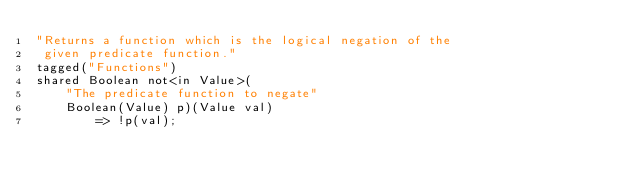<code> <loc_0><loc_0><loc_500><loc_500><_Ceylon_>"Returns a function which is the logical negation of the 
 given predicate function."
tagged("Functions")
shared Boolean not<in Value>(
    "The predicate function to negate"
    Boolean(Value) p)(Value val) 
        => !p(val);</code> 